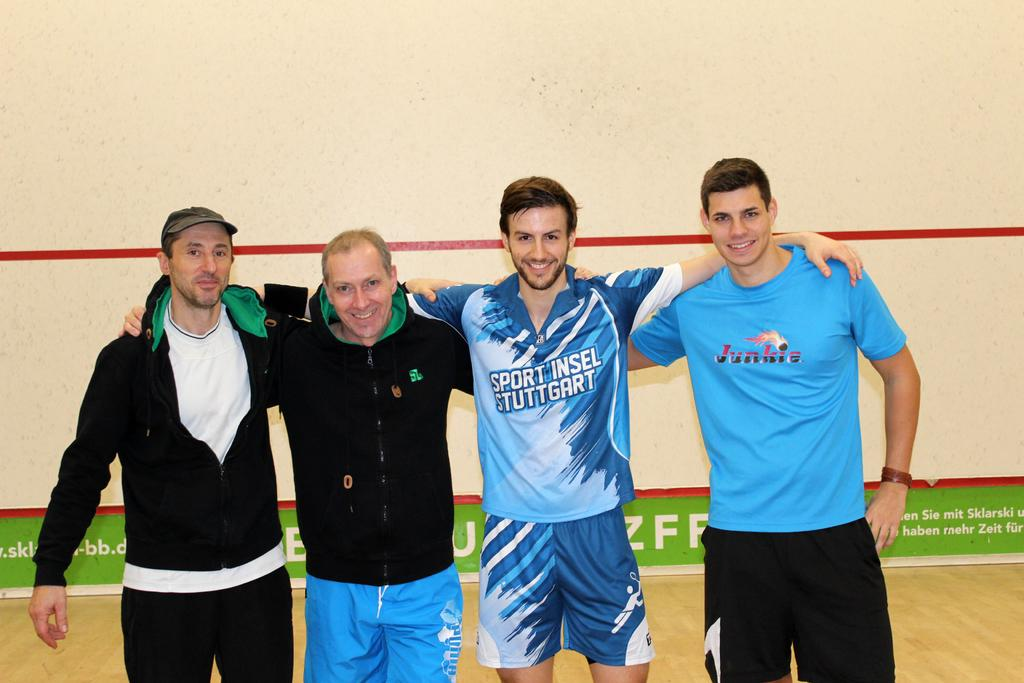<image>
Render a clear and concise summary of the photo. Four men link arms in a gym, one has a t-shirt bearing the words SPort Insel Stuttgart 